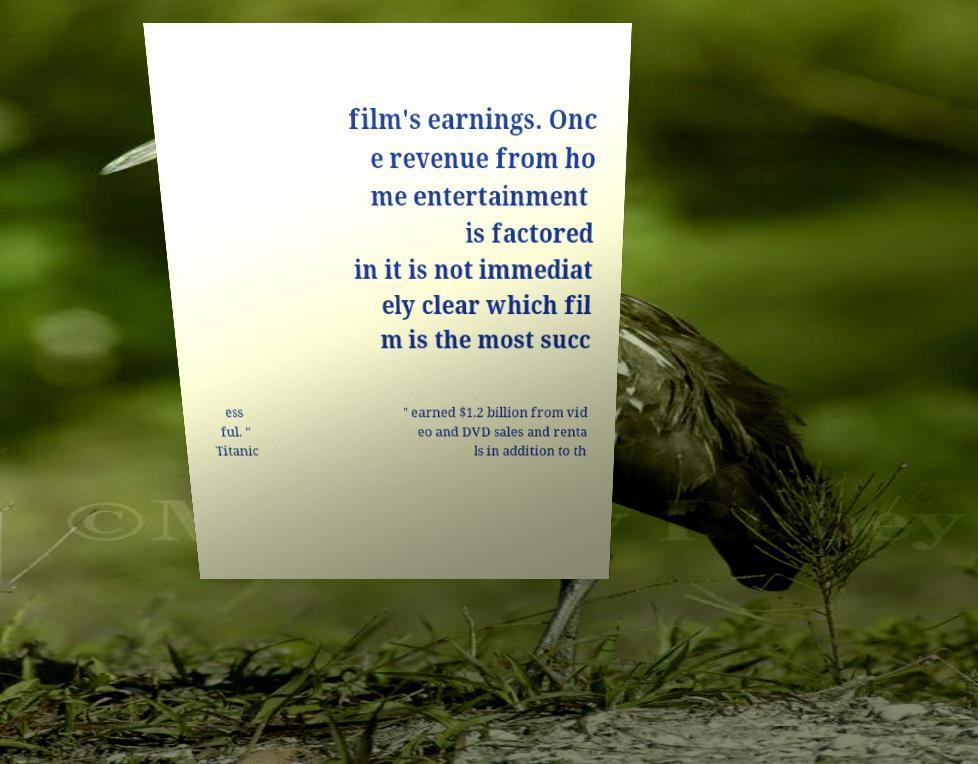Could you extract and type out the text from this image? film's earnings. Onc e revenue from ho me entertainment is factored in it is not immediat ely clear which fil m is the most succ ess ful. " Titanic " earned $1.2 billion from vid eo and DVD sales and renta ls in addition to th 